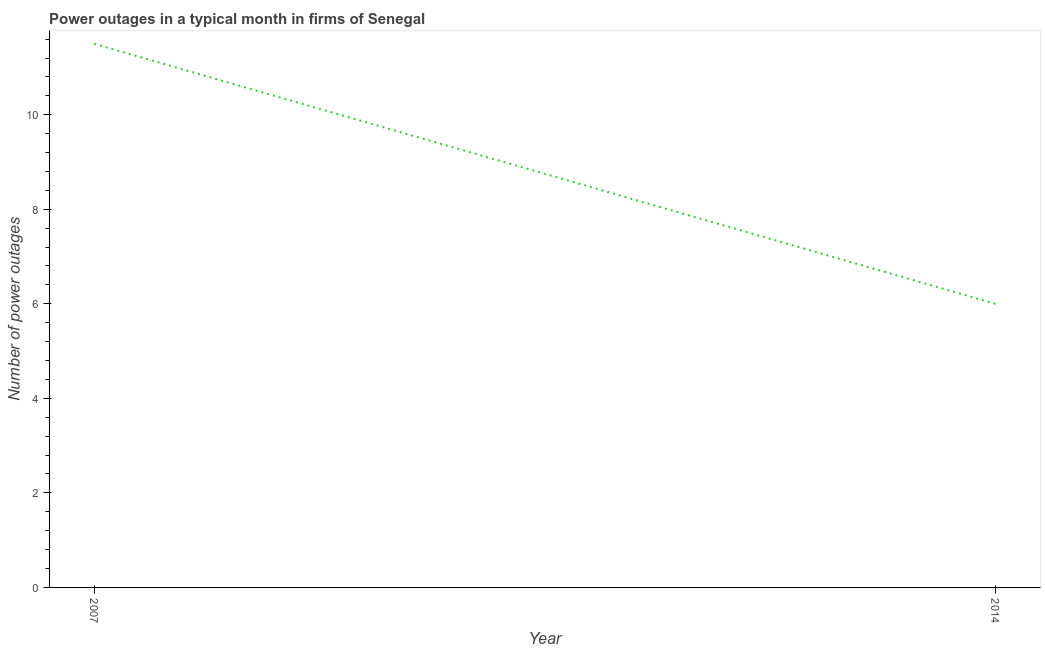What is the number of power outages in 2007?
Provide a short and direct response. 11.5. Across all years, what is the minimum number of power outages?
Provide a succinct answer. 6. In which year was the number of power outages maximum?
Give a very brief answer. 2007. In which year was the number of power outages minimum?
Your response must be concise. 2014. What is the difference between the number of power outages in 2007 and 2014?
Keep it short and to the point. 5.5. What is the average number of power outages per year?
Make the answer very short. 8.75. What is the median number of power outages?
Offer a terse response. 8.75. In how many years, is the number of power outages greater than 3.2 ?
Your answer should be compact. 2. Do a majority of the years between 2007 and 2014 (inclusive) have number of power outages greater than 11.2 ?
Offer a terse response. No. What is the ratio of the number of power outages in 2007 to that in 2014?
Offer a terse response. 1.92. Is the number of power outages in 2007 less than that in 2014?
Provide a short and direct response. No. In how many years, is the number of power outages greater than the average number of power outages taken over all years?
Your answer should be compact. 1. Does the number of power outages monotonically increase over the years?
Keep it short and to the point. No. How many lines are there?
Keep it short and to the point. 1. What is the title of the graph?
Your response must be concise. Power outages in a typical month in firms of Senegal. What is the label or title of the X-axis?
Provide a succinct answer. Year. What is the label or title of the Y-axis?
Provide a succinct answer. Number of power outages. What is the Number of power outages in 2007?
Offer a terse response. 11.5. What is the Number of power outages in 2014?
Your answer should be compact. 6. What is the difference between the Number of power outages in 2007 and 2014?
Your answer should be compact. 5.5. What is the ratio of the Number of power outages in 2007 to that in 2014?
Offer a terse response. 1.92. 